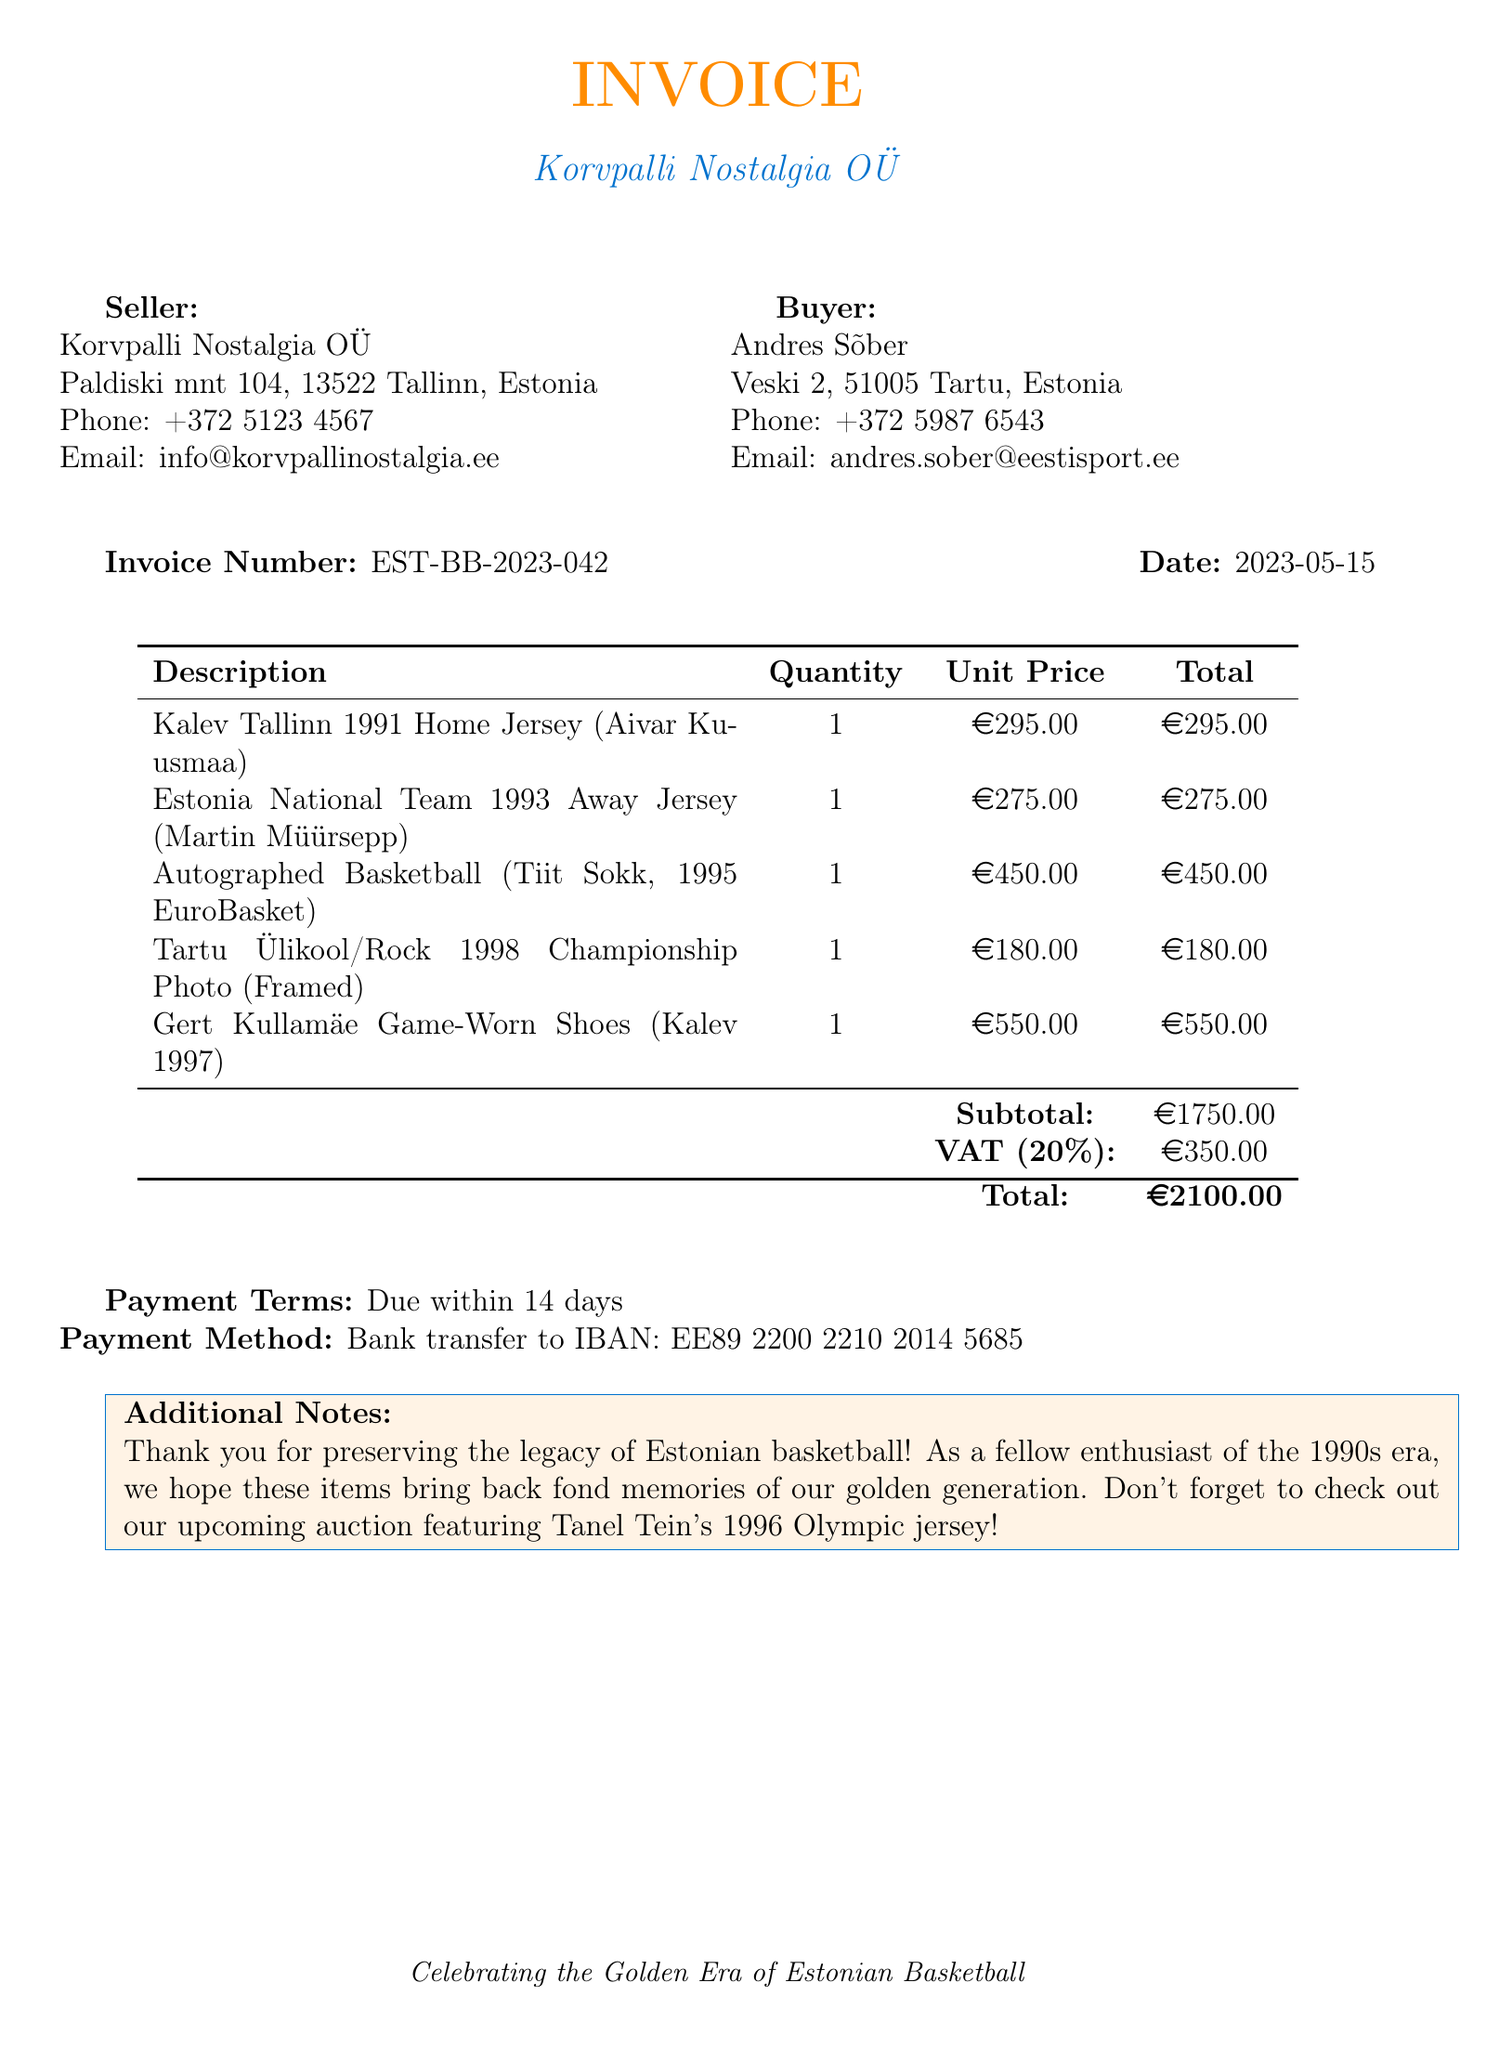What is the invoice number? The invoice number is listed prominently in the document for reference.
Answer: EST-BB-2023-042 What is the date of the invoice? The date is clearly stated in the invoice details section.
Answer: 2023-05-15 Who is the seller? The seller's information is provided at the top of the invoice.
Answer: Korvpalli Nostalgia OÜ What is the total amount due? The total amount is summarized at the bottom of the invoice.
Answer: 2100.00 What is the payment method stated in the invoice? The payment method is specified in the payment terms section of the document.
Answer: Bank transfer to IBAN: EE89 2200 2210 2014 5685 How many items are listed on the invoice? The number of items can be counted in the itemized list.
Answer: 5 What is the VAT amount? The VAT amount is shown as part of the cost breakdown in the invoice.
Answer: 350.00 Which item has the highest unit price? The unit prices are itemized, allowing for a comparison.
Answer: Gert Kullamäe Game-Worn Shoes (Kalev 1997) Who is the buyer? The buyer's details are provided similarly to the seller's information.
Answer: Andres Sõber 